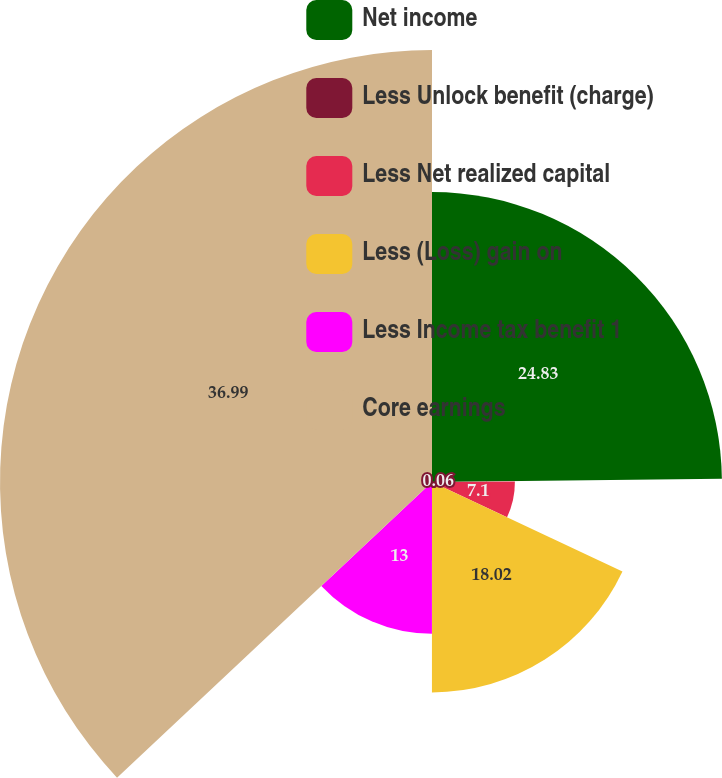Convert chart to OTSL. <chart><loc_0><loc_0><loc_500><loc_500><pie_chart><fcel>Net income<fcel>Less Unlock benefit (charge)<fcel>Less Net realized capital<fcel>Less (Loss) gain on<fcel>Less Income tax benefit 1<fcel>Core earnings<nl><fcel>24.83%<fcel>0.06%<fcel>7.1%<fcel>18.02%<fcel>13.0%<fcel>37.0%<nl></chart> 